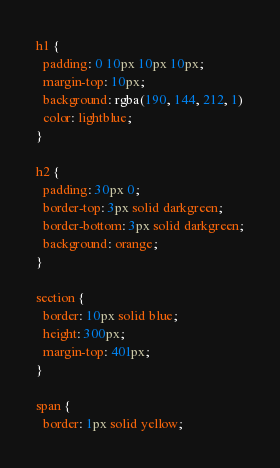Convert code to text. <code><loc_0><loc_0><loc_500><loc_500><_CSS_>h1 {
  padding: 0 10px 10px 10px;
  margin-top: 10px;
  background: rgba(190, 144, 212, 1)
  color: lightblue;
}

h2 {
  padding: 30px 0;
  border-top: 3px solid darkgreen;
  border-bottom: 3px solid darkgreen;
  background: orange;
}

section {
  border: 10px solid blue;
  height: 300px;
  margin-top: 401px;
}

span {
  border: 1px solid yellow;</code> 